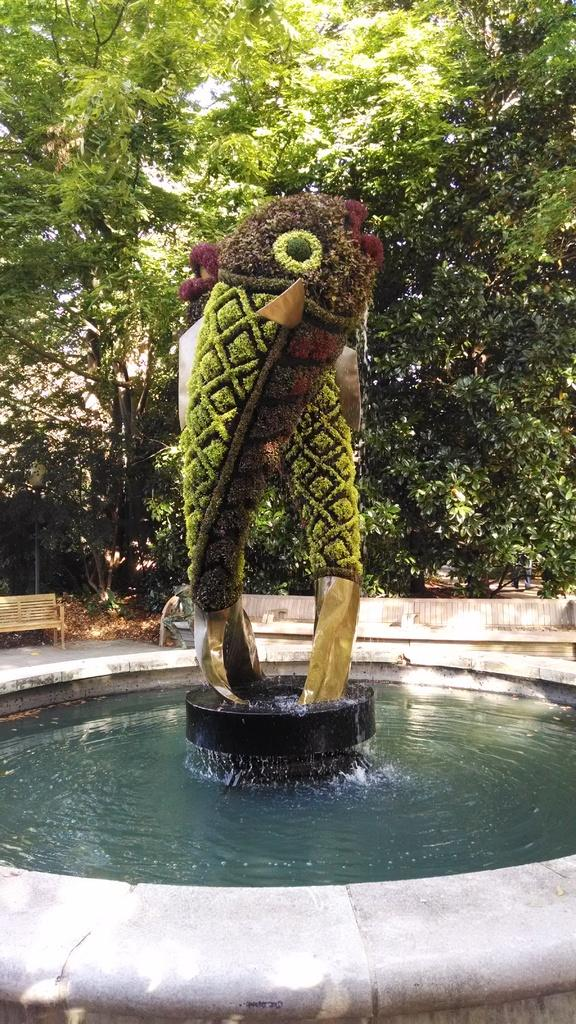What is the primary element in the image? There is water in the image. What structure is present in the water? There is a fountain in the image. What unique feature can be seen in the image? There are trees shaped like fish in the image. What type of vegetation is visible in the background? There are green trees in the background of the image. What objects are present in the background for people to sit on? There are benches in the background of the image. What type of cream is being served on the vest in the image? There is no cream or vest present in the image. 